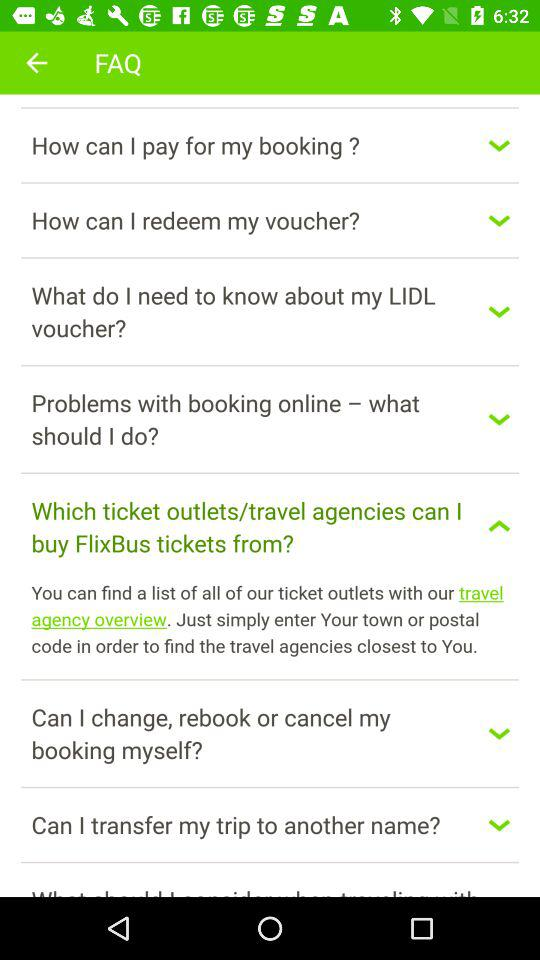How many items are there in the FAQ section?
Answer the question using a single word or phrase. 8 